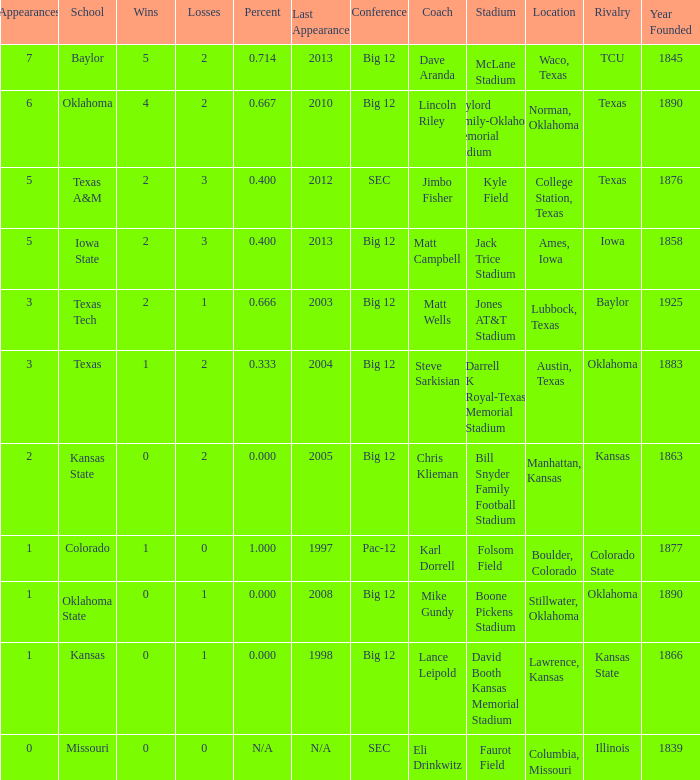Can you give me this table as a dict? {'header': ['Appearances', 'School', 'Wins', 'Losses', 'Percent', 'Last Appearance', 'Conference', 'Coach', 'Stadium', 'Location', 'Rivalry', 'Year Founded'], 'rows': [['7', 'Baylor', '5', '2', '0.714', '2013', 'Big 12', 'Dave Aranda', 'McLane Stadium', 'Waco, Texas', 'TCU', '1845'], ['6', 'Oklahoma', '4', '2', '0.667', '2010', 'Big 12', 'Lincoln Riley', 'Gaylord Family-Oklahoma Memorial Stadium', 'Norman, Oklahoma', 'Texas', '1890'], ['5', 'Texas A&M', '2', '3', '0.400', '2012', 'SEC', 'Jimbo Fisher', 'Kyle Field', 'College Station, Texas', 'Texas', '1876'], ['5', 'Iowa State', '2', '3', '0.400', '2013', 'Big 12', 'Matt Campbell', 'Jack Trice Stadium', 'Ames, Iowa', 'Iowa', '1858'], ['3', 'Texas Tech', '2', '1', '0.666', '2003', 'Big 12', 'Matt Wells', 'Jones AT&T Stadium', 'Lubbock, Texas', 'Baylor', '1925'], ['3', 'Texas', '1', '2', '0.333', '2004', 'Big 12', 'Steve Sarkisian', 'Darrell K Royal-Texas Memorial Stadium', 'Austin, Texas', 'Oklahoma', '1883'], ['2', 'Kansas State', '0', '2', '0.000', '2005', 'Big 12', 'Chris Klieman', 'Bill Snyder Family Football Stadium', 'Manhattan, Kansas', 'Kansas', '1863'], ['1', 'Colorado', '1', '0', '1.000', '1997', 'Pac-12', 'Karl Dorrell', 'Folsom Field', 'Boulder, Colorado', 'Colorado State', '1877'], ['1', 'Oklahoma State', '0', '1', '0.000', '2008', 'Big 12', 'Mike Gundy', 'Boone Pickens Stadium', 'Stillwater, Oklahoma', 'Oklahoma', '1890'], ['1', 'Kansas', '0', '1', '0.000', '1998', 'Big 12', 'Lance Leipold', 'David Booth Kansas Memorial Stadium', 'Lawrence, Kansas', 'Kansas State', '1866'], ['0', 'Missouri', '0', '0', 'N/A', 'N/A', 'SEC', 'Eli Drinkwitz', 'Faurot Field', 'Columbia, Missouri', 'Illinois', '1839']]} What's the largest amount of wins Texas has?  1.0. 